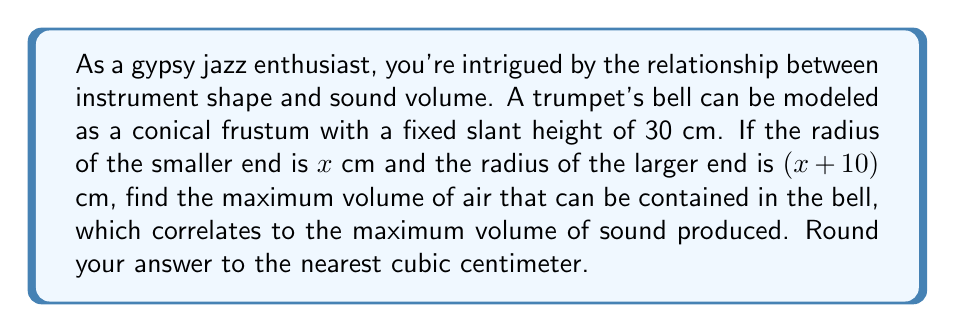Could you help me with this problem? Let's approach this step-by-step:

1) The volume $V$ of a conical frustum is given by the formula:
   $$V = \frac{1}{3}\pi h(r_1^2 + r_1r_2 + r_2^2)$$
   where $h$ is the height, $r_1$ is the radius of the smaller end, and $r_2$ is the radius of the larger end.

2) We're given that $r_1 = x$ and $r_2 = x+10$. We need to express $h$ in terms of $x$.

3) Using the Pythagorean theorem in the triangle formed by the slant height $s$, height $h$, and difference in radii:
   $$s^2 = h^2 + (r_2 - r_1)^2$$
   $$30^2 = h^2 + 10^2$$
   $$h = \sqrt{900 - 100} = \sqrt{800} = 20\sqrt{2}$$

4) Substituting into the volume formula:
   $$V = \frac{1}{3}\pi (20\sqrt{2})(x^2 + x(x+10) + (x+10)^2)$$
   $$V = \frac{20\sqrt{2}\pi}{3}(x^2 + x^2 + 10x + x^2 + 20x + 100)$$
   $$V = \frac{20\sqrt{2}\pi}{3}(3x^2 + 30x + 100)$$

5) To find the maximum volume, we differentiate $V$ with respect to $x$ and set it to zero:
   $$\frac{dV}{dx} = \frac{20\sqrt{2}\pi}{3}(6x + 30) = 0$$

6) Solving this equation:
   $$6x + 30 = 0$$
   $$x = -5$$

7) The second derivative is positive, confirming this is a maximum.

8) The maximum occurs at $x = -5$, but since radius can't be negative, the maximum within our domain occurs at the boundary where $x = 0$.

9) Substituting $x = 0$ into our volume equation:
   $$V = \frac{20\sqrt{2}\pi}{3}(100) = \frac{2000\sqrt{2}\pi}{3} \approx 2962.41$$

10) Rounding to the nearest cubic centimeter gives 2962 cm³.
Answer: 2962 cm³ 